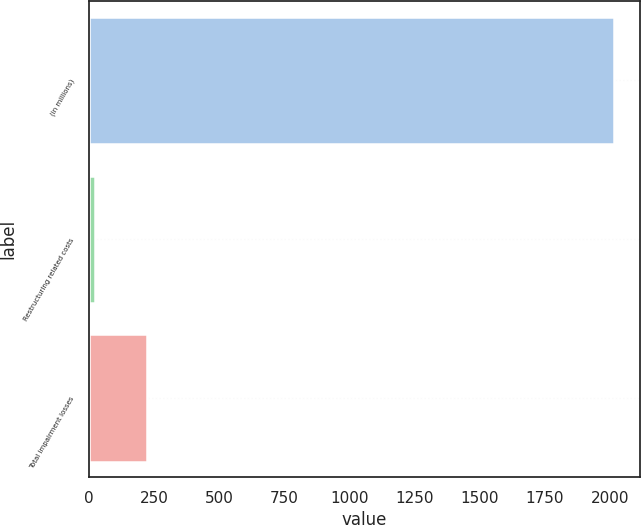Convert chart. <chart><loc_0><loc_0><loc_500><loc_500><bar_chart><fcel>(in millions)<fcel>Restructuring related costs<fcel>Total impairment losses<nl><fcel>2017<fcel>22.4<fcel>221.86<nl></chart> 